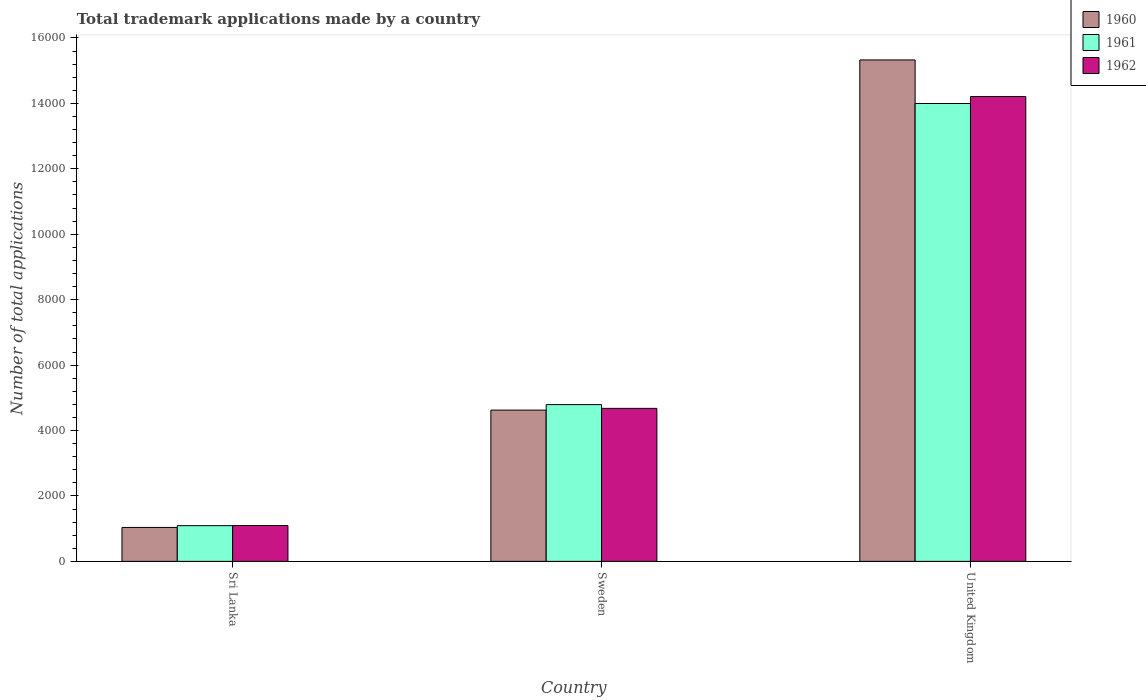Are the number of bars on each tick of the X-axis equal?
Provide a short and direct response. Yes. What is the label of the 1st group of bars from the left?
Keep it short and to the point. Sri Lanka. What is the number of applications made by in 1961 in United Kingdom?
Keep it short and to the point. 1.40e+04. Across all countries, what is the maximum number of applications made by in 1962?
Ensure brevity in your answer.  1.42e+04. Across all countries, what is the minimum number of applications made by in 1961?
Provide a short and direct response. 1092. In which country was the number of applications made by in 1962 maximum?
Ensure brevity in your answer.  United Kingdom. In which country was the number of applications made by in 1962 minimum?
Ensure brevity in your answer.  Sri Lanka. What is the total number of applications made by in 1962 in the graph?
Ensure brevity in your answer.  2.00e+04. What is the difference between the number of applications made by in 1962 in Sweden and that in United Kingdom?
Offer a terse response. -9533. What is the difference between the number of applications made by in 1961 in Sweden and the number of applications made by in 1960 in Sri Lanka?
Your response must be concise. 3755. What is the average number of applications made by in 1962 per country?
Provide a short and direct response. 6660.67. What is the difference between the number of applications made by of/in 1961 and number of applications made by of/in 1960 in Sri Lanka?
Give a very brief answer. 55. In how many countries, is the number of applications made by in 1961 greater than 12000?
Provide a succinct answer. 1. What is the ratio of the number of applications made by in 1961 in Sri Lanka to that in United Kingdom?
Your answer should be very brief. 0.08. Is the difference between the number of applications made by in 1961 in Sri Lanka and Sweden greater than the difference between the number of applications made by in 1960 in Sri Lanka and Sweden?
Offer a very short reply. No. What is the difference between the highest and the second highest number of applications made by in 1962?
Keep it short and to the point. 9533. What is the difference between the highest and the lowest number of applications made by in 1960?
Provide a succinct answer. 1.43e+04. What does the 1st bar from the right in United Kingdom represents?
Provide a succinct answer. 1962. How many bars are there?
Your answer should be compact. 9. What is the difference between two consecutive major ticks on the Y-axis?
Make the answer very short. 2000. Does the graph contain any zero values?
Your answer should be very brief. No. Where does the legend appear in the graph?
Provide a short and direct response. Top right. What is the title of the graph?
Keep it short and to the point. Total trademark applications made by a country. Does "1998" appear as one of the legend labels in the graph?
Your answer should be very brief. No. What is the label or title of the X-axis?
Your answer should be compact. Country. What is the label or title of the Y-axis?
Your response must be concise. Number of total applications. What is the Number of total applications in 1960 in Sri Lanka?
Ensure brevity in your answer.  1037. What is the Number of total applications of 1961 in Sri Lanka?
Make the answer very short. 1092. What is the Number of total applications in 1962 in Sri Lanka?
Your response must be concise. 1095. What is the Number of total applications in 1960 in Sweden?
Your response must be concise. 4624. What is the Number of total applications in 1961 in Sweden?
Offer a very short reply. 4792. What is the Number of total applications in 1962 in Sweden?
Keep it short and to the point. 4677. What is the Number of total applications of 1960 in United Kingdom?
Provide a short and direct response. 1.53e+04. What is the Number of total applications of 1961 in United Kingdom?
Offer a terse response. 1.40e+04. What is the Number of total applications of 1962 in United Kingdom?
Your answer should be very brief. 1.42e+04. Across all countries, what is the maximum Number of total applications in 1960?
Ensure brevity in your answer.  1.53e+04. Across all countries, what is the maximum Number of total applications of 1961?
Ensure brevity in your answer.  1.40e+04. Across all countries, what is the maximum Number of total applications of 1962?
Offer a terse response. 1.42e+04. Across all countries, what is the minimum Number of total applications of 1960?
Your answer should be compact. 1037. Across all countries, what is the minimum Number of total applications in 1961?
Your response must be concise. 1092. Across all countries, what is the minimum Number of total applications of 1962?
Your response must be concise. 1095. What is the total Number of total applications of 1960 in the graph?
Give a very brief answer. 2.10e+04. What is the total Number of total applications in 1961 in the graph?
Provide a succinct answer. 1.99e+04. What is the total Number of total applications in 1962 in the graph?
Ensure brevity in your answer.  2.00e+04. What is the difference between the Number of total applications in 1960 in Sri Lanka and that in Sweden?
Provide a short and direct response. -3587. What is the difference between the Number of total applications of 1961 in Sri Lanka and that in Sweden?
Provide a succinct answer. -3700. What is the difference between the Number of total applications in 1962 in Sri Lanka and that in Sweden?
Your answer should be compact. -3582. What is the difference between the Number of total applications of 1960 in Sri Lanka and that in United Kingdom?
Offer a terse response. -1.43e+04. What is the difference between the Number of total applications in 1961 in Sri Lanka and that in United Kingdom?
Offer a terse response. -1.29e+04. What is the difference between the Number of total applications in 1962 in Sri Lanka and that in United Kingdom?
Offer a terse response. -1.31e+04. What is the difference between the Number of total applications in 1960 in Sweden and that in United Kingdom?
Ensure brevity in your answer.  -1.07e+04. What is the difference between the Number of total applications of 1961 in Sweden and that in United Kingdom?
Ensure brevity in your answer.  -9205. What is the difference between the Number of total applications in 1962 in Sweden and that in United Kingdom?
Your response must be concise. -9533. What is the difference between the Number of total applications of 1960 in Sri Lanka and the Number of total applications of 1961 in Sweden?
Provide a succinct answer. -3755. What is the difference between the Number of total applications in 1960 in Sri Lanka and the Number of total applications in 1962 in Sweden?
Provide a short and direct response. -3640. What is the difference between the Number of total applications of 1961 in Sri Lanka and the Number of total applications of 1962 in Sweden?
Offer a very short reply. -3585. What is the difference between the Number of total applications of 1960 in Sri Lanka and the Number of total applications of 1961 in United Kingdom?
Provide a succinct answer. -1.30e+04. What is the difference between the Number of total applications in 1960 in Sri Lanka and the Number of total applications in 1962 in United Kingdom?
Make the answer very short. -1.32e+04. What is the difference between the Number of total applications of 1961 in Sri Lanka and the Number of total applications of 1962 in United Kingdom?
Your answer should be very brief. -1.31e+04. What is the difference between the Number of total applications of 1960 in Sweden and the Number of total applications of 1961 in United Kingdom?
Provide a short and direct response. -9373. What is the difference between the Number of total applications of 1960 in Sweden and the Number of total applications of 1962 in United Kingdom?
Offer a very short reply. -9586. What is the difference between the Number of total applications in 1961 in Sweden and the Number of total applications in 1962 in United Kingdom?
Provide a short and direct response. -9418. What is the average Number of total applications in 1960 per country?
Your response must be concise. 6996.33. What is the average Number of total applications in 1961 per country?
Your answer should be compact. 6627. What is the average Number of total applications in 1962 per country?
Keep it short and to the point. 6660.67. What is the difference between the Number of total applications of 1960 and Number of total applications of 1961 in Sri Lanka?
Provide a succinct answer. -55. What is the difference between the Number of total applications in 1960 and Number of total applications in 1962 in Sri Lanka?
Make the answer very short. -58. What is the difference between the Number of total applications of 1960 and Number of total applications of 1961 in Sweden?
Provide a succinct answer. -168. What is the difference between the Number of total applications of 1960 and Number of total applications of 1962 in Sweden?
Make the answer very short. -53. What is the difference between the Number of total applications in 1961 and Number of total applications in 1962 in Sweden?
Ensure brevity in your answer.  115. What is the difference between the Number of total applications of 1960 and Number of total applications of 1961 in United Kingdom?
Give a very brief answer. 1331. What is the difference between the Number of total applications in 1960 and Number of total applications in 1962 in United Kingdom?
Ensure brevity in your answer.  1118. What is the difference between the Number of total applications of 1961 and Number of total applications of 1962 in United Kingdom?
Make the answer very short. -213. What is the ratio of the Number of total applications in 1960 in Sri Lanka to that in Sweden?
Give a very brief answer. 0.22. What is the ratio of the Number of total applications in 1961 in Sri Lanka to that in Sweden?
Your answer should be very brief. 0.23. What is the ratio of the Number of total applications of 1962 in Sri Lanka to that in Sweden?
Provide a short and direct response. 0.23. What is the ratio of the Number of total applications in 1960 in Sri Lanka to that in United Kingdom?
Make the answer very short. 0.07. What is the ratio of the Number of total applications in 1961 in Sri Lanka to that in United Kingdom?
Offer a terse response. 0.08. What is the ratio of the Number of total applications of 1962 in Sri Lanka to that in United Kingdom?
Give a very brief answer. 0.08. What is the ratio of the Number of total applications of 1960 in Sweden to that in United Kingdom?
Your answer should be very brief. 0.3. What is the ratio of the Number of total applications of 1961 in Sweden to that in United Kingdom?
Provide a short and direct response. 0.34. What is the ratio of the Number of total applications of 1962 in Sweden to that in United Kingdom?
Provide a succinct answer. 0.33. What is the difference between the highest and the second highest Number of total applications in 1960?
Offer a terse response. 1.07e+04. What is the difference between the highest and the second highest Number of total applications of 1961?
Your answer should be compact. 9205. What is the difference between the highest and the second highest Number of total applications of 1962?
Ensure brevity in your answer.  9533. What is the difference between the highest and the lowest Number of total applications of 1960?
Keep it short and to the point. 1.43e+04. What is the difference between the highest and the lowest Number of total applications of 1961?
Ensure brevity in your answer.  1.29e+04. What is the difference between the highest and the lowest Number of total applications of 1962?
Your answer should be very brief. 1.31e+04. 